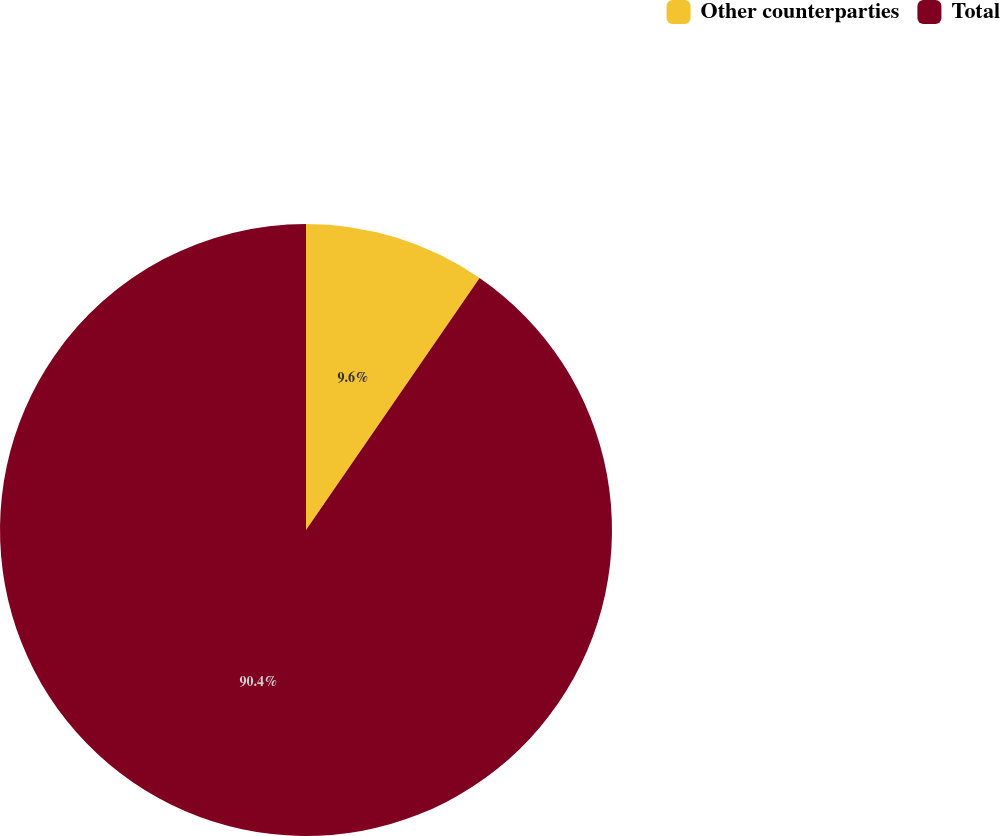Convert chart. <chart><loc_0><loc_0><loc_500><loc_500><pie_chart><fcel>Other counterparties<fcel>Total<nl><fcel>9.6%<fcel>90.4%<nl></chart> 